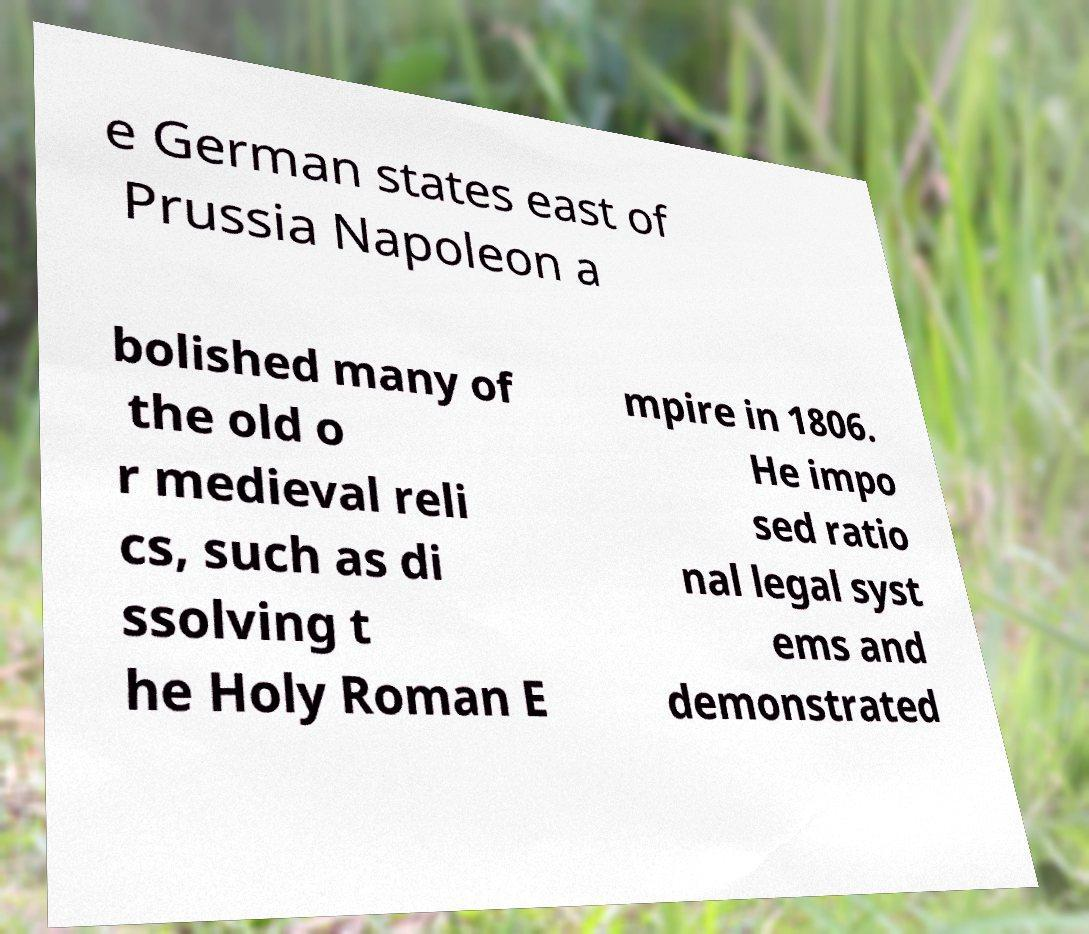Could you extract and type out the text from this image? e German states east of Prussia Napoleon a bolished many of the old o r medieval reli cs, such as di ssolving t he Holy Roman E mpire in 1806. He impo sed ratio nal legal syst ems and demonstrated 